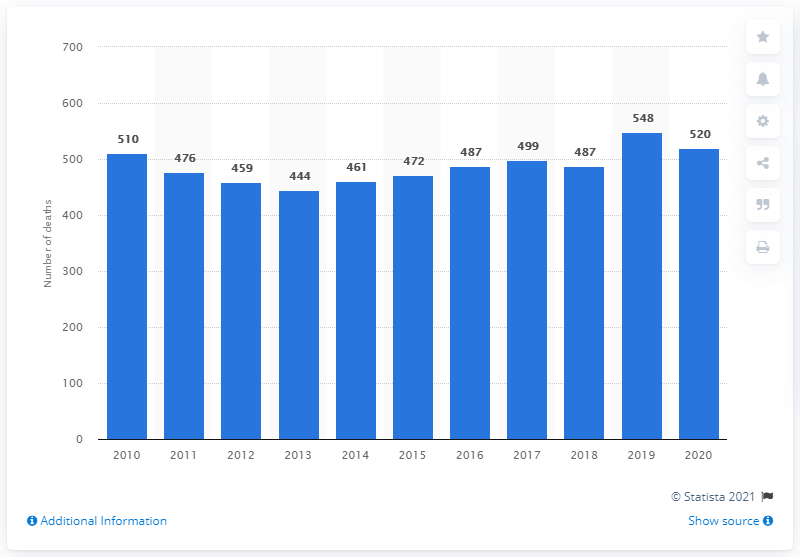Mention a couple of crucial points in this snapshot. In 2020, the number of deaths in Greenland was 520. 